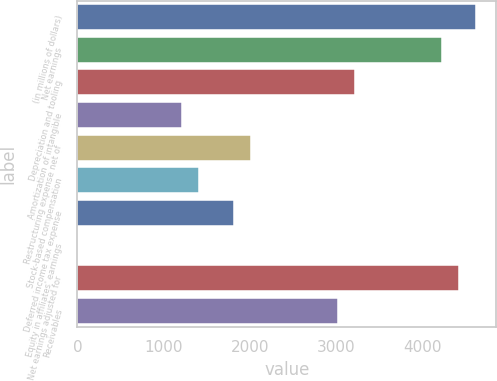<chart> <loc_0><loc_0><loc_500><loc_500><bar_chart><fcel>(in millions of dollars)<fcel>Net earnings<fcel>Depreciation and tooling<fcel>Amortization of intangible<fcel>Restructuring expense net of<fcel>Stock-based compensation<fcel>Deferred income tax expense<fcel>Equity in affiliates' earnings<fcel>Net earnings adjusted for<fcel>Receivables<nl><fcel>4629.47<fcel>4227.09<fcel>3221.14<fcel>1209.24<fcel>2014<fcel>1410.43<fcel>1812.81<fcel>2.1<fcel>4428.28<fcel>3019.95<nl></chart> 